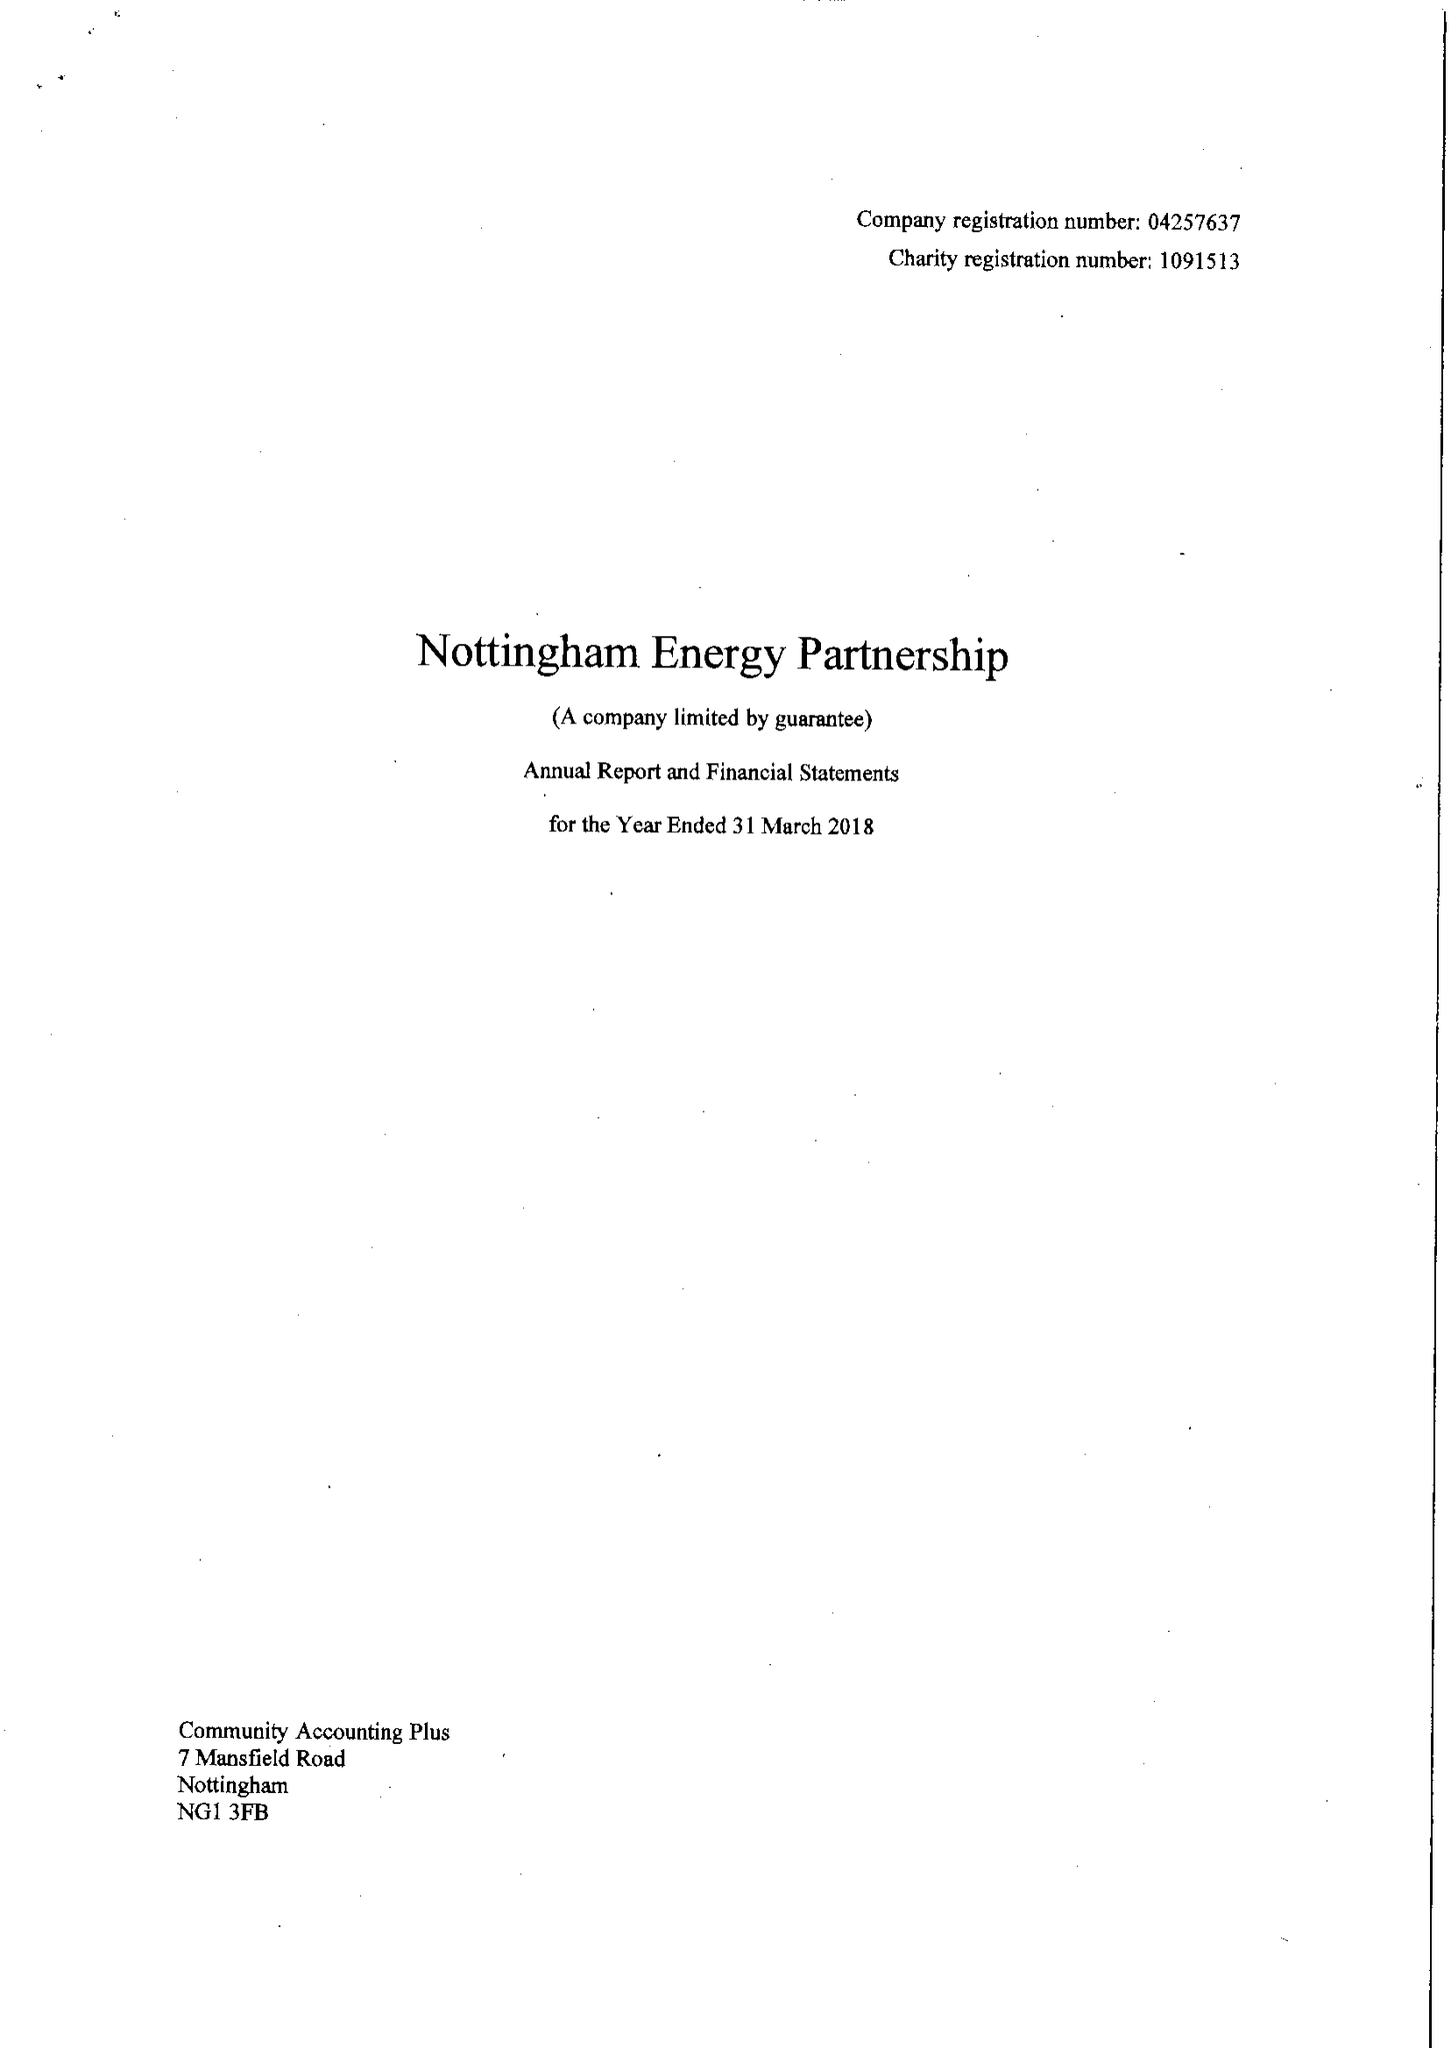What is the value for the charity_number?
Answer the question using a single word or phrase. 1091513 